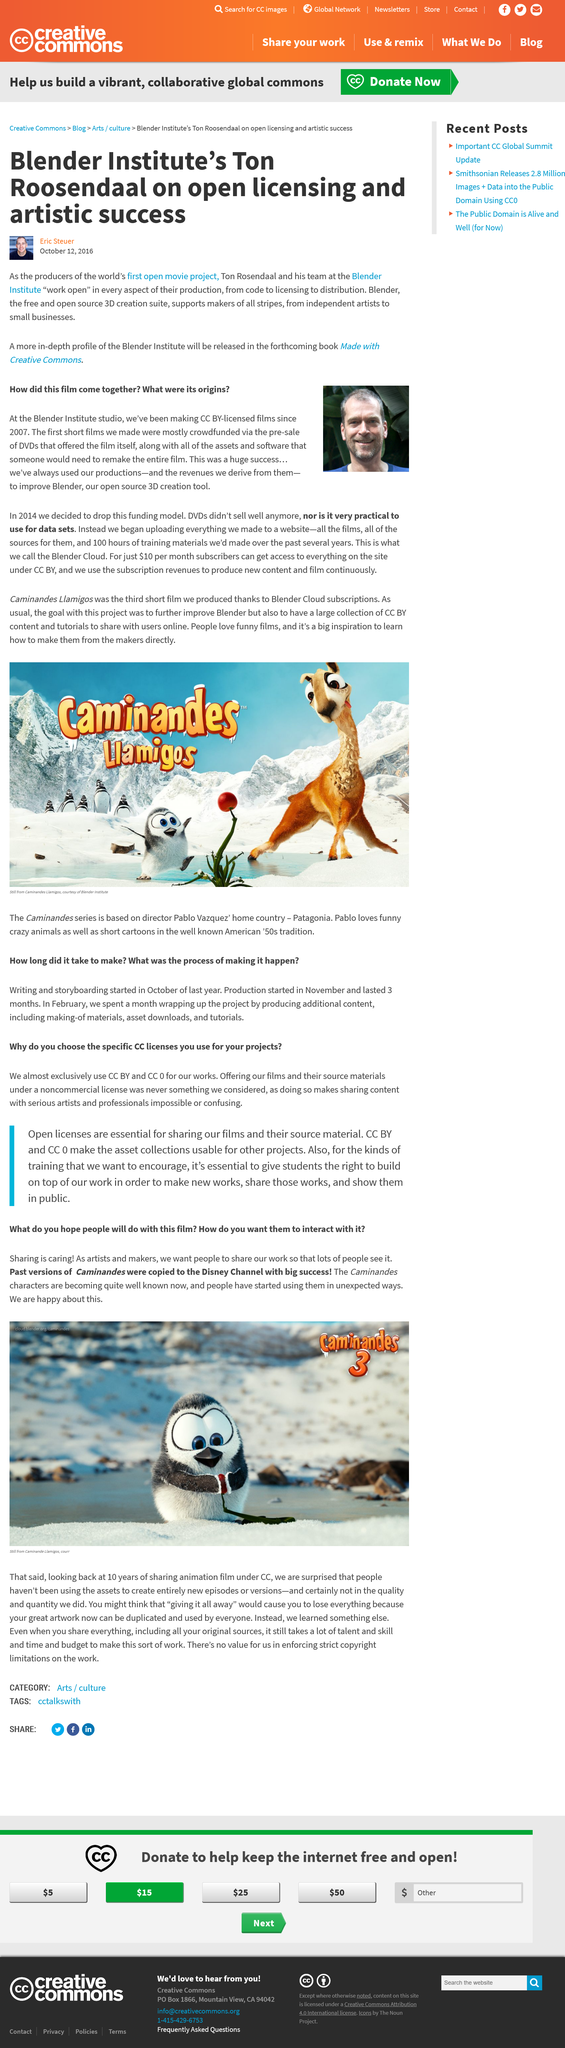Identify some key points in this picture. The title of the movie depicted in the pictured caption is "Caminandes 3. The Blender Institute studio has been producing and licensing CC BY-licensed films. Blender is an open-source 3D creation tool that enables users to design and create 3D models, animations, and visual effects. In the past, previous versions of Caminandes were copied to great success and were successfully transferred to the Disney Channel. The Blender Institute team, led by Ton Rosendaal, produced the world's first open movie project. 